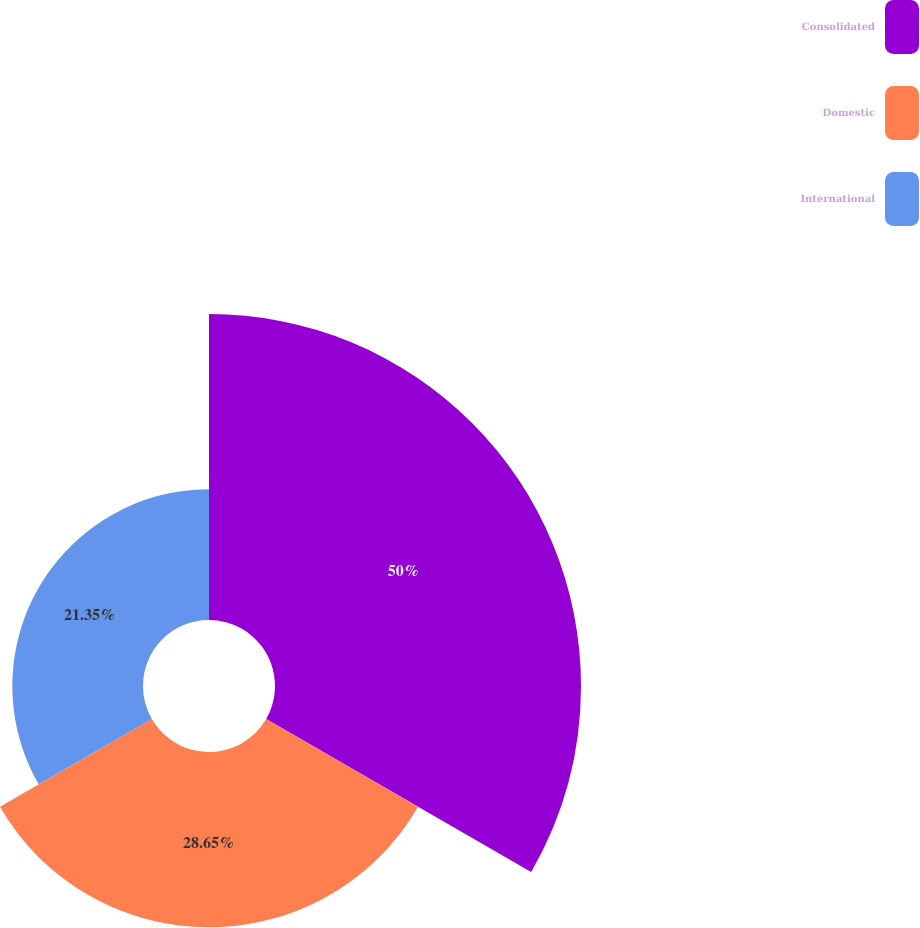Convert chart. <chart><loc_0><loc_0><loc_500><loc_500><pie_chart><fcel>Consolidated<fcel>Domestic<fcel>International<nl><fcel>50.0%<fcel>28.65%<fcel>21.35%<nl></chart> 